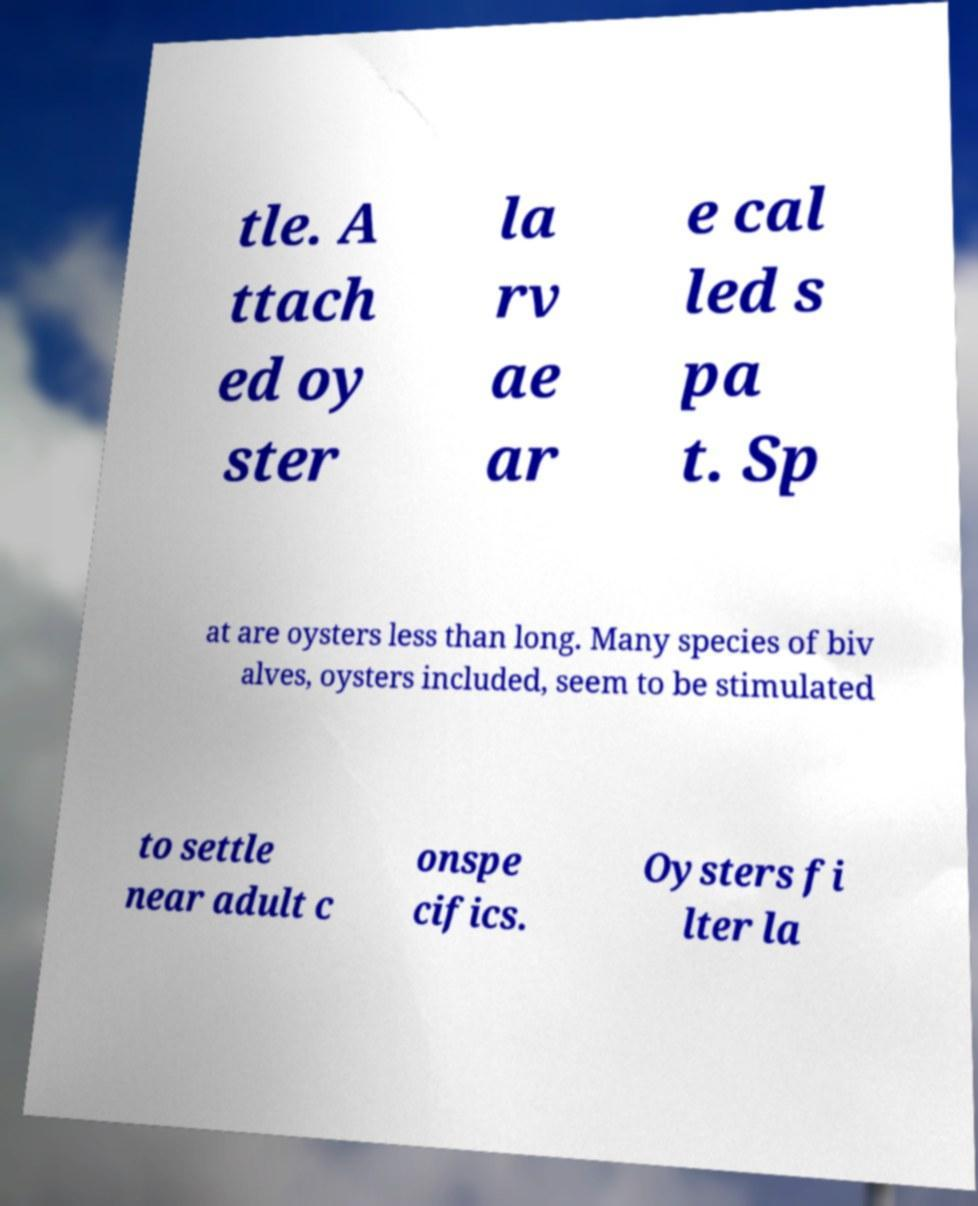Can you accurately transcribe the text from the provided image for me? tle. A ttach ed oy ster la rv ae ar e cal led s pa t. Sp at are oysters less than long. Many species of biv alves, oysters included, seem to be stimulated to settle near adult c onspe cifics. Oysters fi lter la 